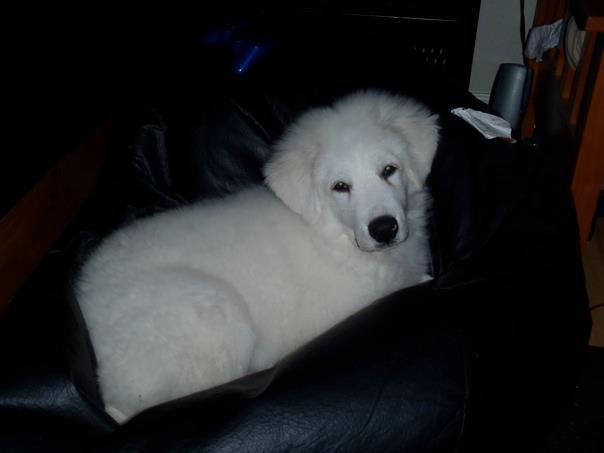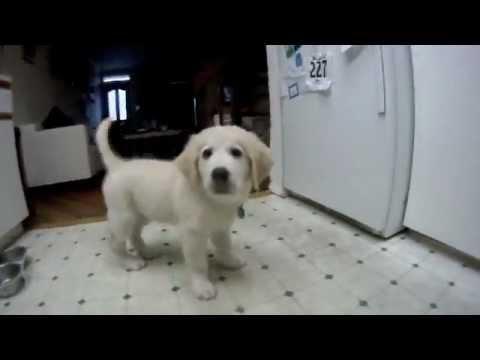The first image is the image on the left, the second image is the image on the right. Assess this claim about the two images: "The dog in the image on the left is lying on the grass.". Correct or not? Answer yes or no. No. The first image is the image on the left, the second image is the image on the right. Given the left and right images, does the statement "An image shows one white dog reclining on the grass with its front paws extended." hold true? Answer yes or no. No. 